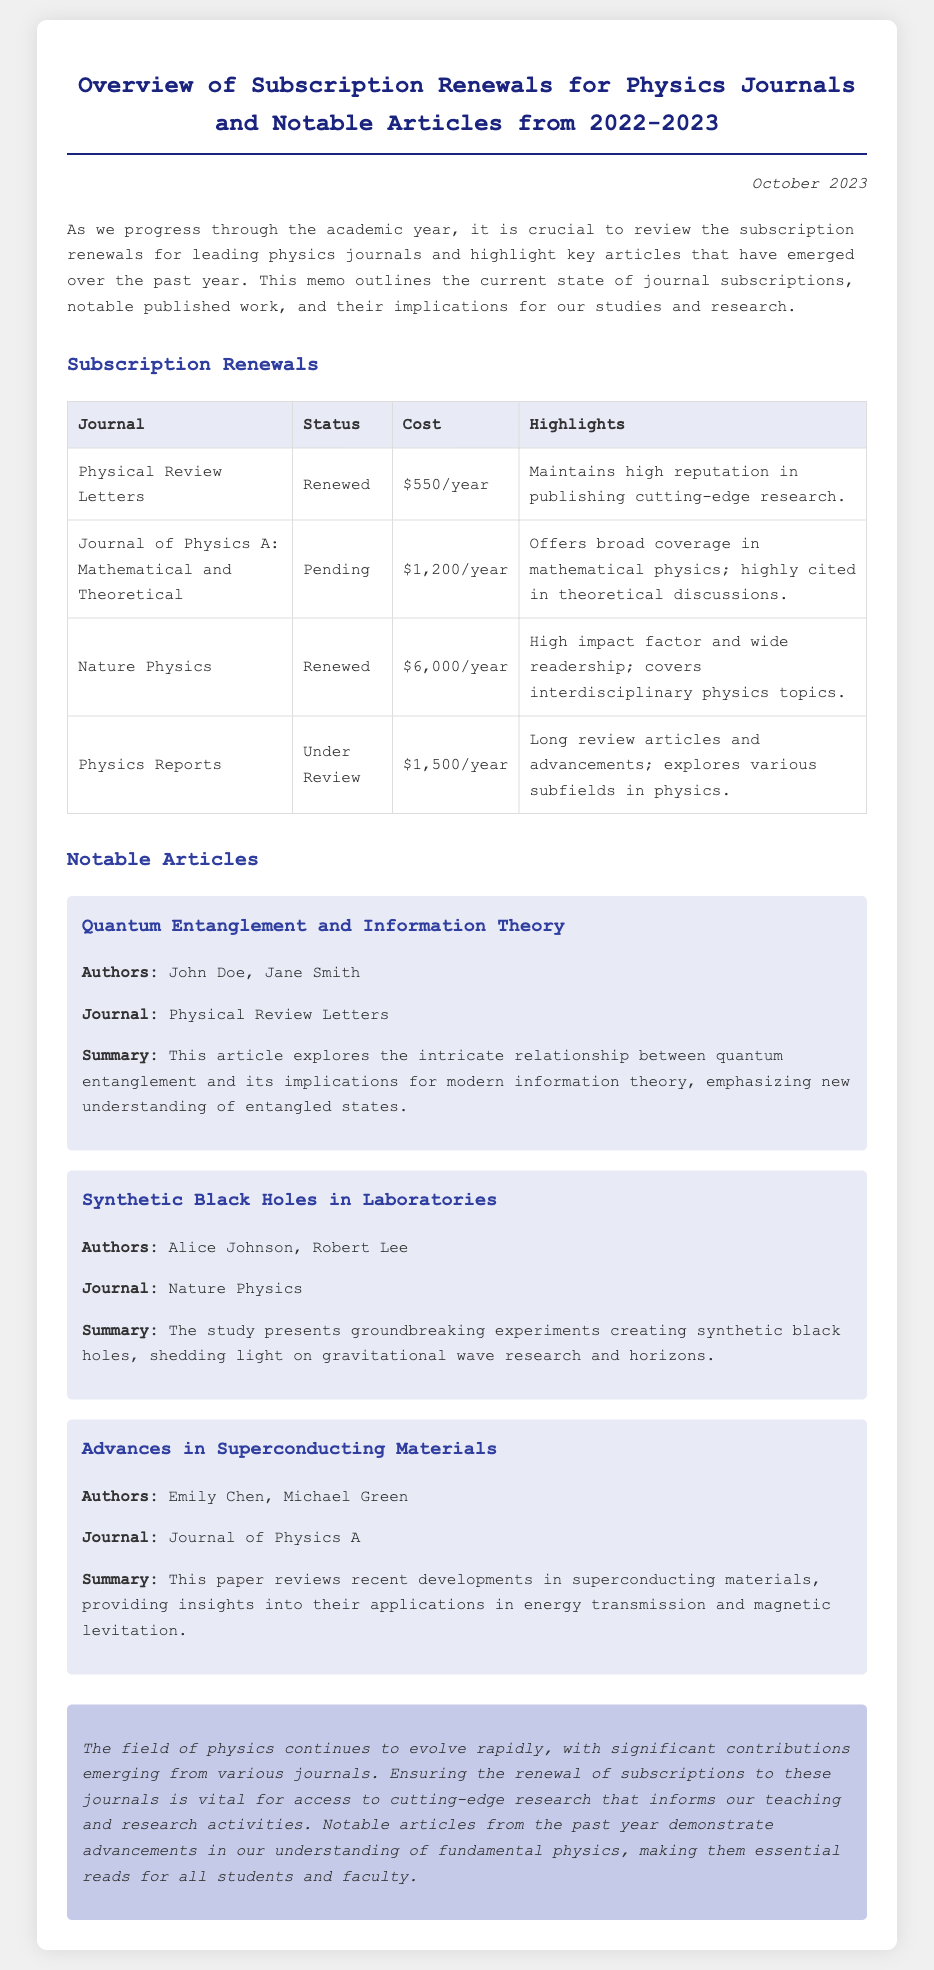What is the title of the memo? The title of the memo describes the main subject, which is an overview of subscription renewals and notable articles.
Answer: Overview of Subscription Renewals for Physics Journals and Notable Articles from 2022-2023 What is the publication status of the Journal of Physics A? The status indicates whether the subscription for the journal has been renewed, is pending, or under review.
Answer: Pending How much is the subscription cost for Nature Physics? The cost information is provided in the subscription table for each journal.
Answer: $6,000/year Who are the authors of the article "Synthetic Black Holes in Laboratories"? The authors are listed in the notable articles section under each title.
Answer: Alice Johnson, Robert Lee What was a highlight mentioned for Physical Review Letters? The highlights provide a brief insight into the journal's reputation or focus area.
Answer: Maintains high reputation in publishing cutting-edge research Which journal is currently under review for renewal? This question asks for the specific journal that has not yet received a renewal approval.
Answer: Physics Reports What type of article does the memo highlight from the Journal of Physics A? This requires linking the journal name to a specific type of research discussed in the memo.
Answer: Advances in Superconducting Materials What is the main purpose of the memo? The purpose encapsulates the overall objective or message expressed in the opening paragraph.
Answer: Review subscription renewals and highlight key articles 